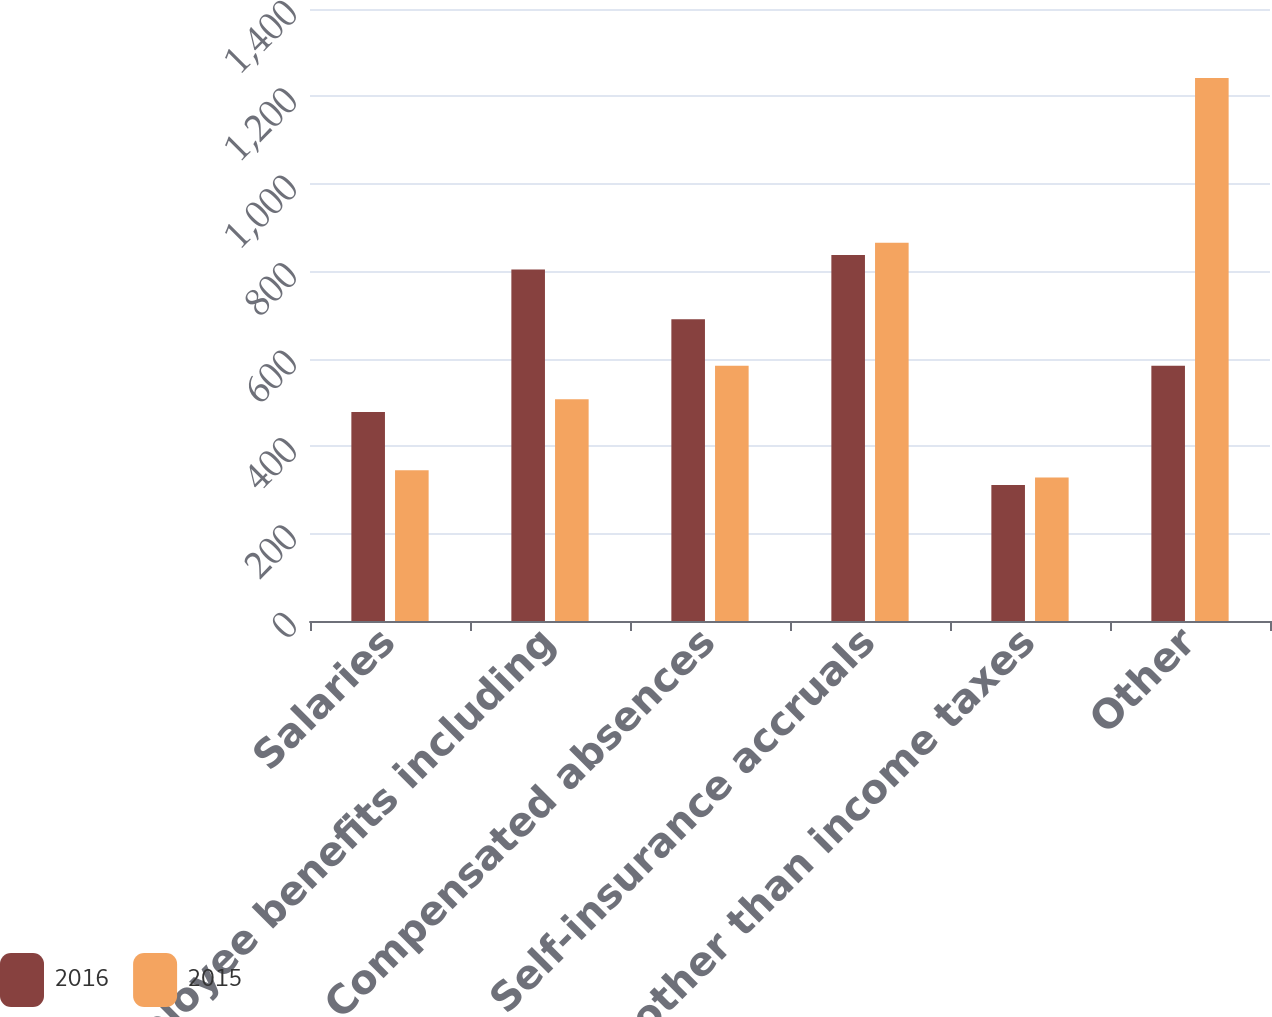<chart> <loc_0><loc_0><loc_500><loc_500><stacked_bar_chart><ecel><fcel>Salaries<fcel>Employee benefits including<fcel>Compensated absences<fcel>Self-insurance accruals<fcel>Taxes other than income taxes<fcel>Other<nl><fcel>2016<fcel>478<fcel>804<fcel>690<fcel>837<fcel>311<fcel>584<nl><fcel>2015<fcel>345<fcel>507<fcel>584<fcel>865<fcel>328<fcel>1242<nl></chart> 